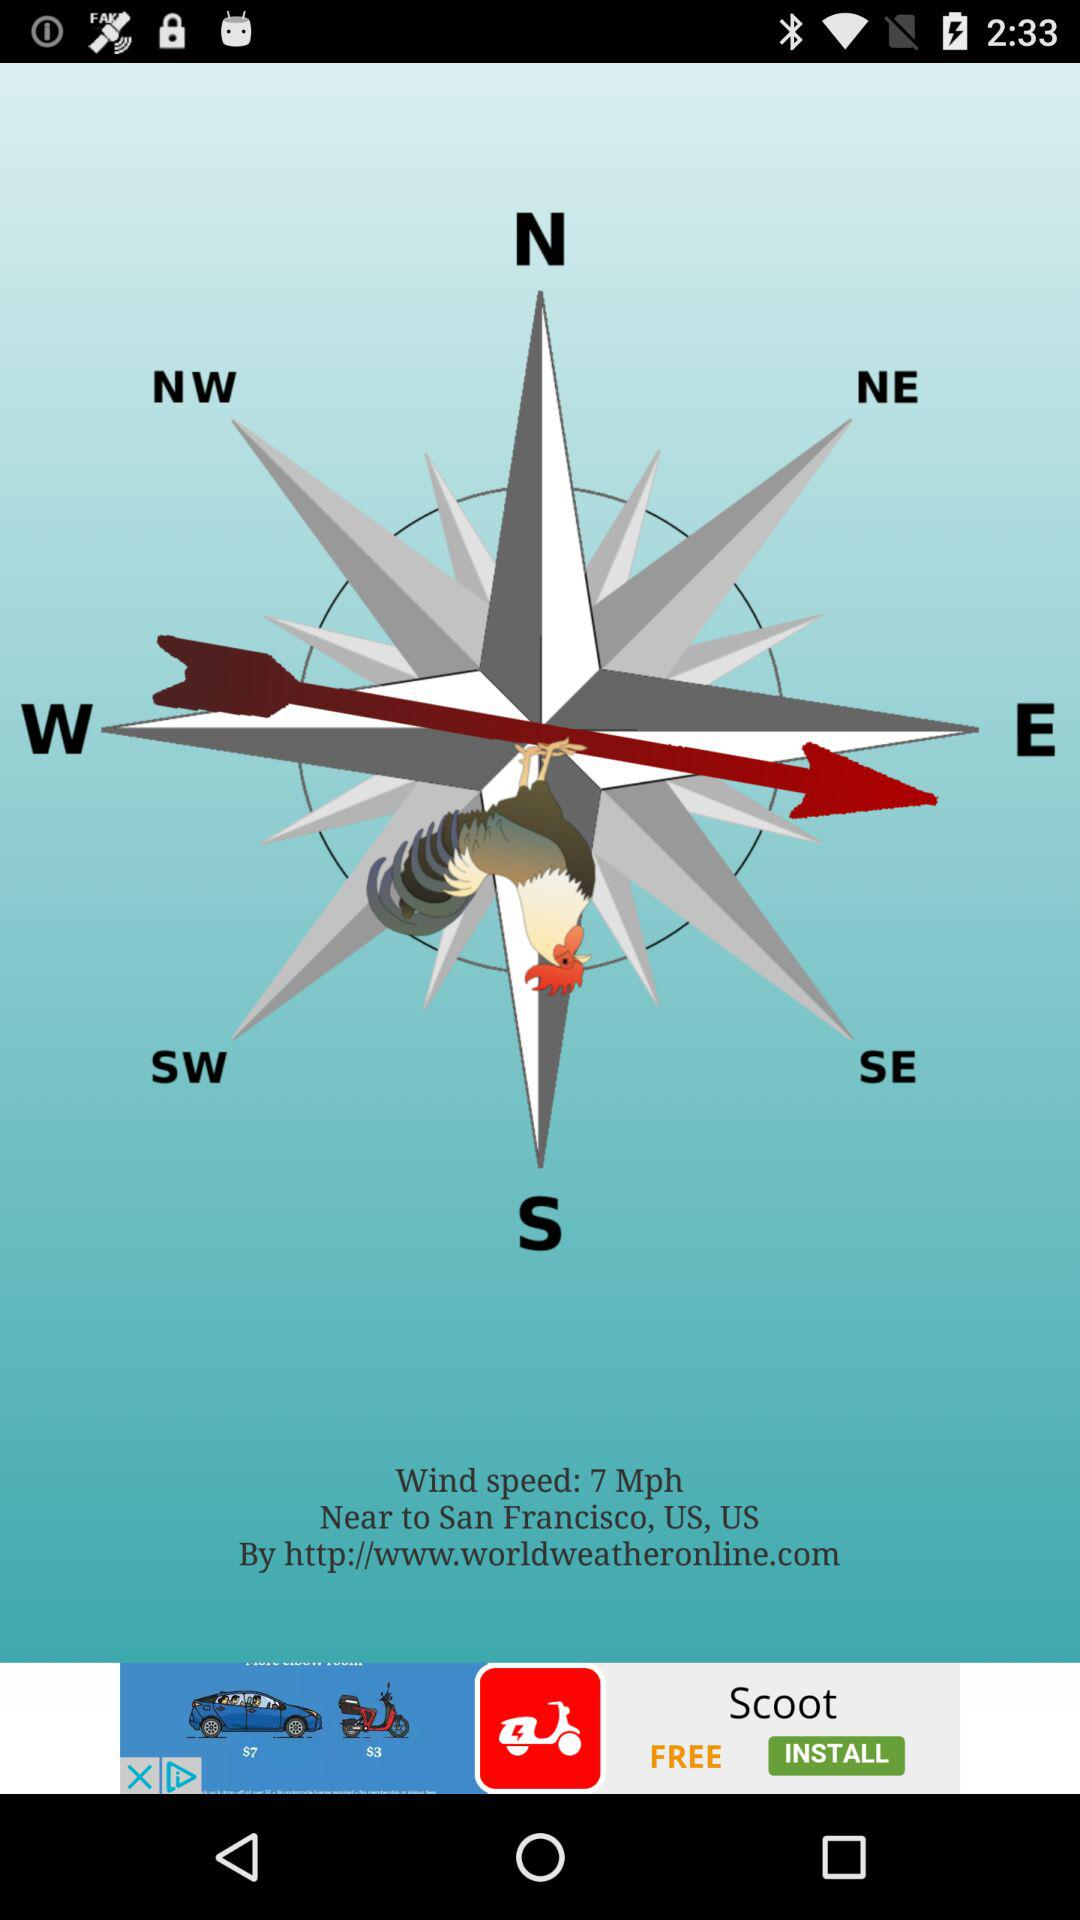What is the given wind speed? The given wind speed is 7 mph. 